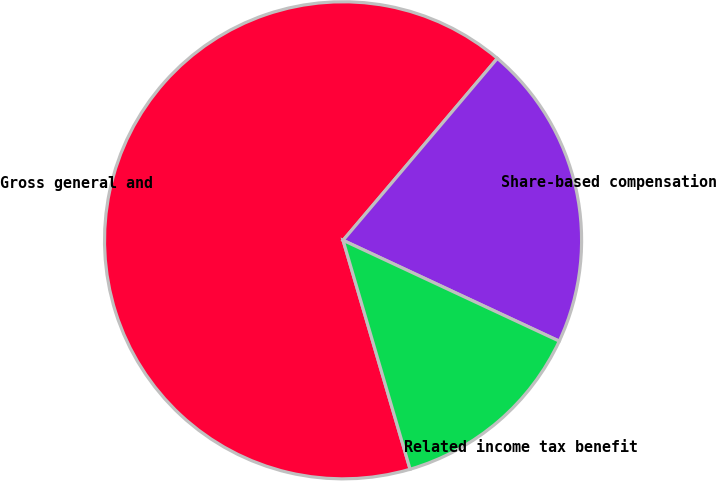Convert chart. <chart><loc_0><loc_0><loc_500><loc_500><pie_chart><fcel>Gross general and<fcel>Share-based compensation<fcel>Related income tax benefit<nl><fcel>65.72%<fcel>20.75%<fcel>13.52%<nl></chart> 